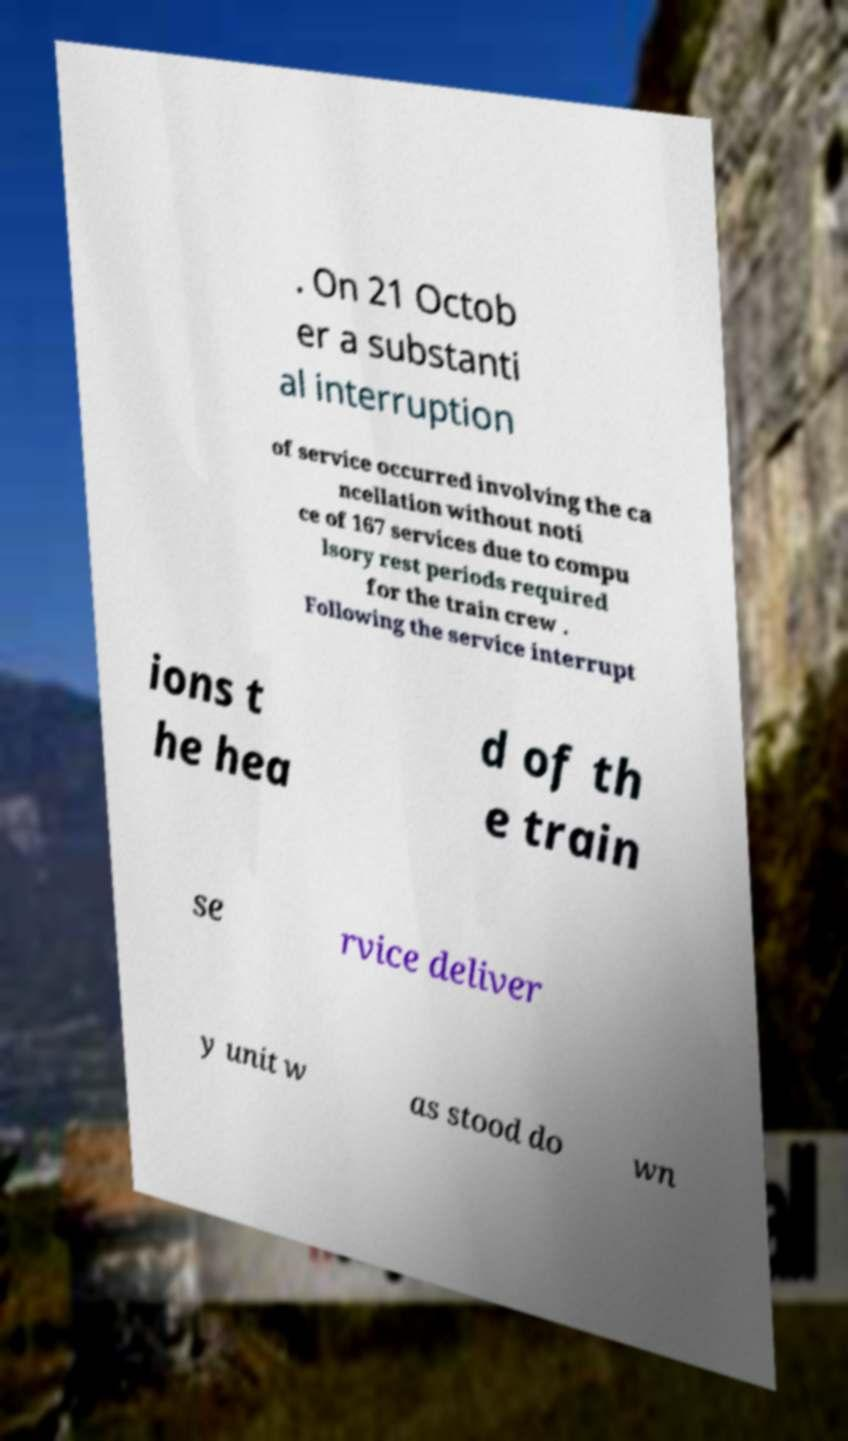There's text embedded in this image that I need extracted. Can you transcribe it verbatim? . On 21 Octob er a substanti al interruption of service occurred involving the ca ncellation without noti ce of 167 services due to compu lsory rest periods required for the train crew . Following the service interrupt ions t he hea d of th e train se rvice deliver y unit w as stood do wn 